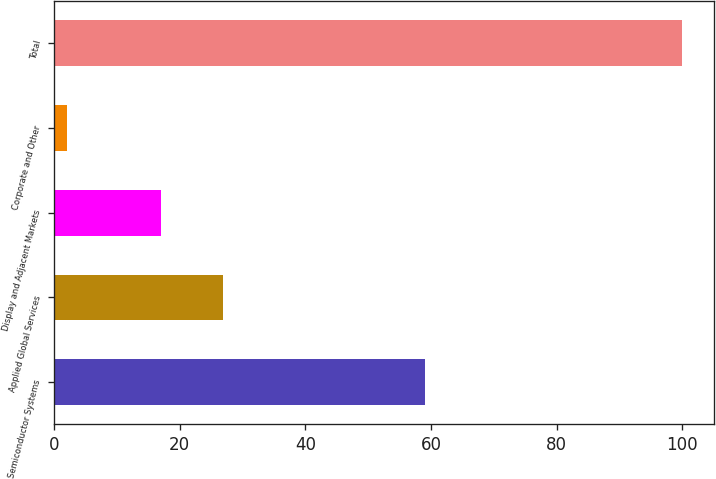Convert chart. <chart><loc_0><loc_0><loc_500><loc_500><bar_chart><fcel>Semiconductor Systems<fcel>Applied Global Services<fcel>Display and Adjacent Markets<fcel>Corporate and Other<fcel>Total<nl><fcel>59<fcel>26.8<fcel>17<fcel>2<fcel>100<nl></chart> 